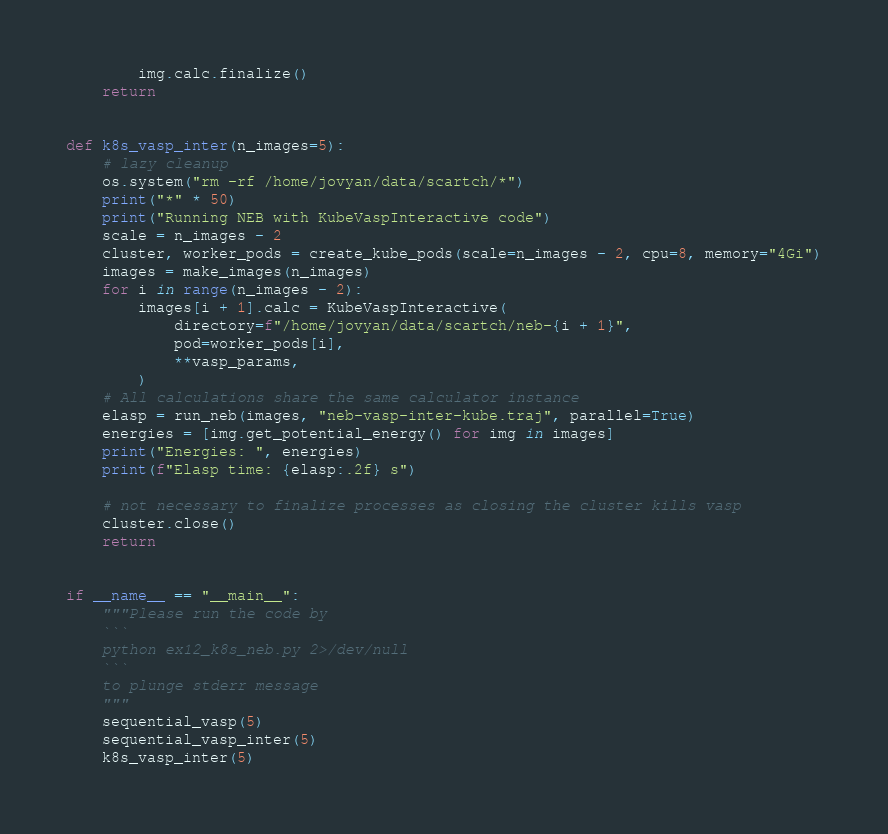<code> <loc_0><loc_0><loc_500><loc_500><_Python_>        img.calc.finalize()
    return


def k8s_vasp_inter(n_images=5):
    # lazy cleanup
    os.system("rm -rf /home/jovyan/data/scartch/*")
    print("*" * 50)
    print("Running NEB with KubeVaspInteractive code")
    scale = n_images - 2
    cluster, worker_pods = create_kube_pods(scale=n_images - 2, cpu=8, memory="4Gi")
    images = make_images(n_images)
    for i in range(n_images - 2):
        images[i + 1].calc = KubeVaspInteractive(
            directory=f"/home/jovyan/data/scartch/neb-{i + 1}",
            pod=worker_pods[i],
            **vasp_params,
        )
    # All calculations share the same calculator instance
    elasp = run_neb(images, "neb-vasp-inter-kube.traj", parallel=True)
    energies = [img.get_potential_energy() for img in images]
    print("Energies: ", energies)
    print(f"Elasp time: {elasp:.2f} s")

    # not necessary to finalize processes as closing the cluster kills vasp
    cluster.close()
    return


if __name__ == "__main__":
    """Please run the code by
    ```
    python ex12_k8s_neb.py 2>/dev/null
    ```
    to plunge stderr message
    """
    sequential_vasp(5)
    sequential_vasp_inter(5)
    k8s_vasp_inter(5)
</code> 